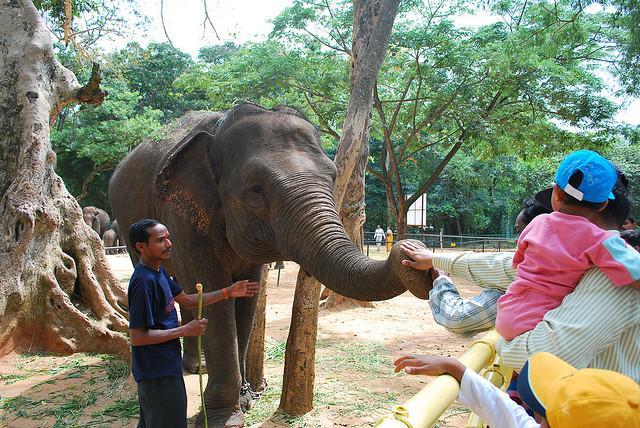What Disney cartoon character is based on this animal? Please explain your reasoning. dumbo. The animal is an elephant. 